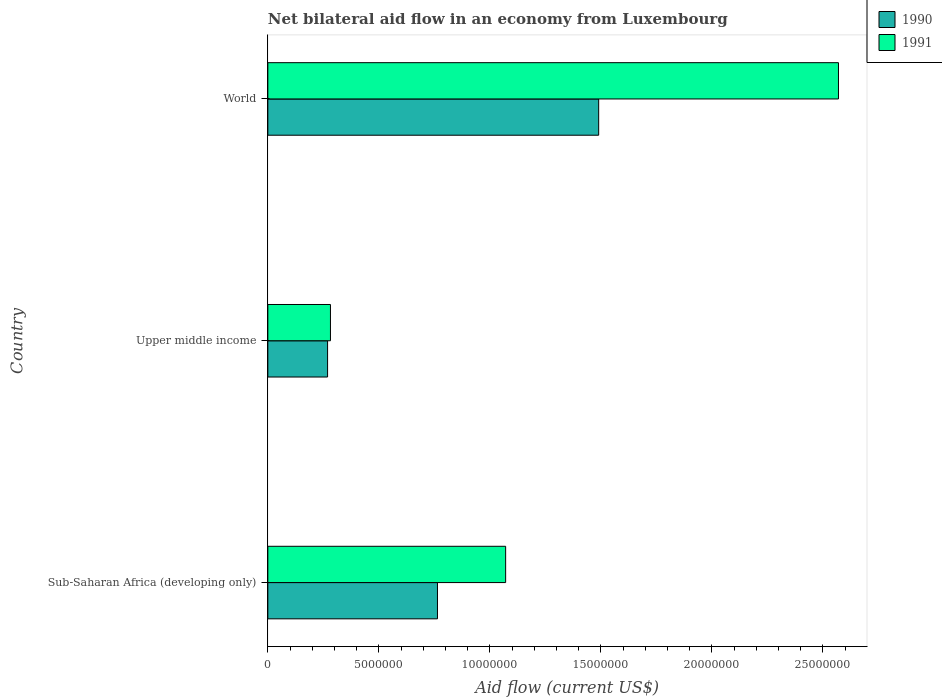Are the number of bars on each tick of the Y-axis equal?
Give a very brief answer. Yes. How many bars are there on the 3rd tick from the bottom?
Ensure brevity in your answer.  2. What is the label of the 1st group of bars from the top?
Make the answer very short. World. What is the net bilateral aid flow in 1991 in Upper middle income?
Provide a short and direct response. 2.82e+06. Across all countries, what is the maximum net bilateral aid flow in 1991?
Keep it short and to the point. 2.57e+07. Across all countries, what is the minimum net bilateral aid flow in 1991?
Your response must be concise. 2.82e+06. In which country was the net bilateral aid flow in 1990 maximum?
Provide a short and direct response. World. In which country was the net bilateral aid flow in 1991 minimum?
Make the answer very short. Upper middle income. What is the total net bilateral aid flow in 1990 in the graph?
Keep it short and to the point. 2.52e+07. What is the difference between the net bilateral aid flow in 1990 in Sub-Saharan Africa (developing only) and that in Upper middle income?
Keep it short and to the point. 4.95e+06. What is the difference between the net bilateral aid flow in 1990 in Upper middle income and the net bilateral aid flow in 1991 in World?
Offer a terse response. -2.30e+07. What is the average net bilateral aid flow in 1991 per country?
Provide a succinct answer. 1.31e+07. What is the difference between the net bilateral aid flow in 1990 and net bilateral aid flow in 1991 in Upper middle income?
Ensure brevity in your answer.  -1.30e+05. What is the ratio of the net bilateral aid flow in 1990 in Sub-Saharan Africa (developing only) to that in Upper middle income?
Your response must be concise. 2.84. Is the net bilateral aid flow in 1991 in Sub-Saharan Africa (developing only) less than that in World?
Ensure brevity in your answer.  Yes. What is the difference between the highest and the second highest net bilateral aid flow in 1990?
Provide a short and direct response. 7.26e+06. What is the difference between the highest and the lowest net bilateral aid flow in 1991?
Keep it short and to the point. 2.29e+07. In how many countries, is the net bilateral aid flow in 1990 greater than the average net bilateral aid flow in 1990 taken over all countries?
Your response must be concise. 1. What does the 1st bar from the top in Upper middle income represents?
Your response must be concise. 1991. How many bars are there?
Offer a terse response. 6. Are all the bars in the graph horizontal?
Your answer should be very brief. Yes. How many countries are there in the graph?
Provide a succinct answer. 3. Does the graph contain any zero values?
Give a very brief answer. No. Does the graph contain grids?
Make the answer very short. No. Where does the legend appear in the graph?
Offer a very short reply. Top right. How are the legend labels stacked?
Make the answer very short. Vertical. What is the title of the graph?
Offer a very short reply. Net bilateral aid flow in an economy from Luxembourg. What is the Aid flow (current US$) in 1990 in Sub-Saharan Africa (developing only)?
Offer a terse response. 7.64e+06. What is the Aid flow (current US$) of 1991 in Sub-Saharan Africa (developing only)?
Keep it short and to the point. 1.07e+07. What is the Aid flow (current US$) of 1990 in Upper middle income?
Offer a terse response. 2.69e+06. What is the Aid flow (current US$) in 1991 in Upper middle income?
Provide a short and direct response. 2.82e+06. What is the Aid flow (current US$) of 1990 in World?
Provide a succinct answer. 1.49e+07. What is the Aid flow (current US$) of 1991 in World?
Make the answer very short. 2.57e+07. Across all countries, what is the maximum Aid flow (current US$) in 1990?
Your response must be concise. 1.49e+07. Across all countries, what is the maximum Aid flow (current US$) of 1991?
Your answer should be compact. 2.57e+07. Across all countries, what is the minimum Aid flow (current US$) in 1990?
Make the answer very short. 2.69e+06. Across all countries, what is the minimum Aid flow (current US$) in 1991?
Your answer should be compact. 2.82e+06. What is the total Aid flow (current US$) in 1990 in the graph?
Your response must be concise. 2.52e+07. What is the total Aid flow (current US$) in 1991 in the graph?
Provide a short and direct response. 3.92e+07. What is the difference between the Aid flow (current US$) in 1990 in Sub-Saharan Africa (developing only) and that in Upper middle income?
Ensure brevity in your answer.  4.95e+06. What is the difference between the Aid flow (current US$) of 1991 in Sub-Saharan Africa (developing only) and that in Upper middle income?
Provide a short and direct response. 7.89e+06. What is the difference between the Aid flow (current US$) in 1990 in Sub-Saharan Africa (developing only) and that in World?
Offer a terse response. -7.26e+06. What is the difference between the Aid flow (current US$) in 1991 in Sub-Saharan Africa (developing only) and that in World?
Offer a very short reply. -1.50e+07. What is the difference between the Aid flow (current US$) in 1990 in Upper middle income and that in World?
Give a very brief answer. -1.22e+07. What is the difference between the Aid flow (current US$) in 1991 in Upper middle income and that in World?
Offer a terse response. -2.29e+07. What is the difference between the Aid flow (current US$) of 1990 in Sub-Saharan Africa (developing only) and the Aid flow (current US$) of 1991 in Upper middle income?
Offer a very short reply. 4.82e+06. What is the difference between the Aid flow (current US$) in 1990 in Sub-Saharan Africa (developing only) and the Aid flow (current US$) in 1991 in World?
Give a very brief answer. -1.81e+07. What is the difference between the Aid flow (current US$) in 1990 in Upper middle income and the Aid flow (current US$) in 1991 in World?
Ensure brevity in your answer.  -2.30e+07. What is the average Aid flow (current US$) of 1990 per country?
Provide a succinct answer. 8.41e+06. What is the average Aid flow (current US$) in 1991 per country?
Give a very brief answer. 1.31e+07. What is the difference between the Aid flow (current US$) of 1990 and Aid flow (current US$) of 1991 in Sub-Saharan Africa (developing only)?
Ensure brevity in your answer.  -3.07e+06. What is the difference between the Aid flow (current US$) in 1990 and Aid flow (current US$) in 1991 in World?
Provide a short and direct response. -1.08e+07. What is the ratio of the Aid flow (current US$) in 1990 in Sub-Saharan Africa (developing only) to that in Upper middle income?
Give a very brief answer. 2.84. What is the ratio of the Aid flow (current US$) in 1991 in Sub-Saharan Africa (developing only) to that in Upper middle income?
Your answer should be very brief. 3.8. What is the ratio of the Aid flow (current US$) of 1990 in Sub-Saharan Africa (developing only) to that in World?
Provide a short and direct response. 0.51. What is the ratio of the Aid flow (current US$) in 1991 in Sub-Saharan Africa (developing only) to that in World?
Offer a terse response. 0.42. What is the ratio of the Aid flow (current US$) in 1990 in Upper middle income to that in World?
Offer a very short reply. 0.18. What is the ratio of the Aid flow (current US$) in 1991 in Upper middle income to that in World?
Give a very brief answer. 0.11. What is the difference between the highest and the second highest Aid flow (current US$) in 1990?
Your answer should be very brief. 7.26e+06. What is the difference between the highest and the second highest Aid flow (current US$) of 1991?
Give a very brief answer. 1.50e+07. What is the difference between the highest and the lowest Aid flow (current US$) in 1990?
Your answer should be compact. 1.22e+07. What is the difference between the highest and the lowest Aid flow (current US$) in 1991?
Provide a short and direct response. 2.29e+07. 